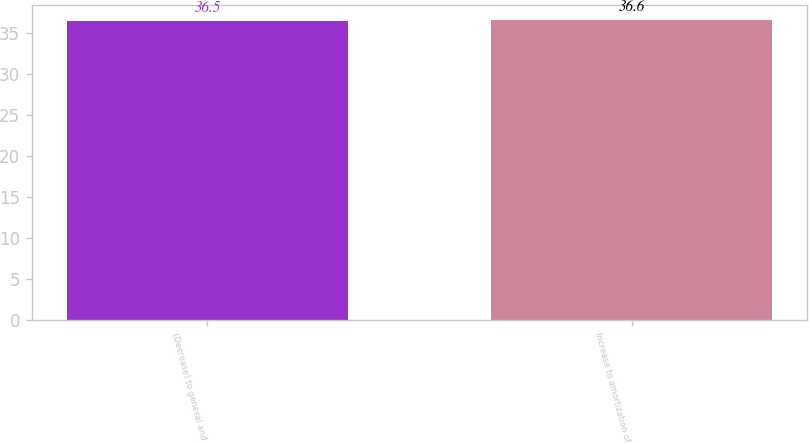<chart> <loc_0><loc_0><loc_500><loc_500><bar_chart><fcel>(Decrease) to general and<fcel>Increase to amortization of<nl><fcel>36.5<fcel>36.6<nl></chart> 